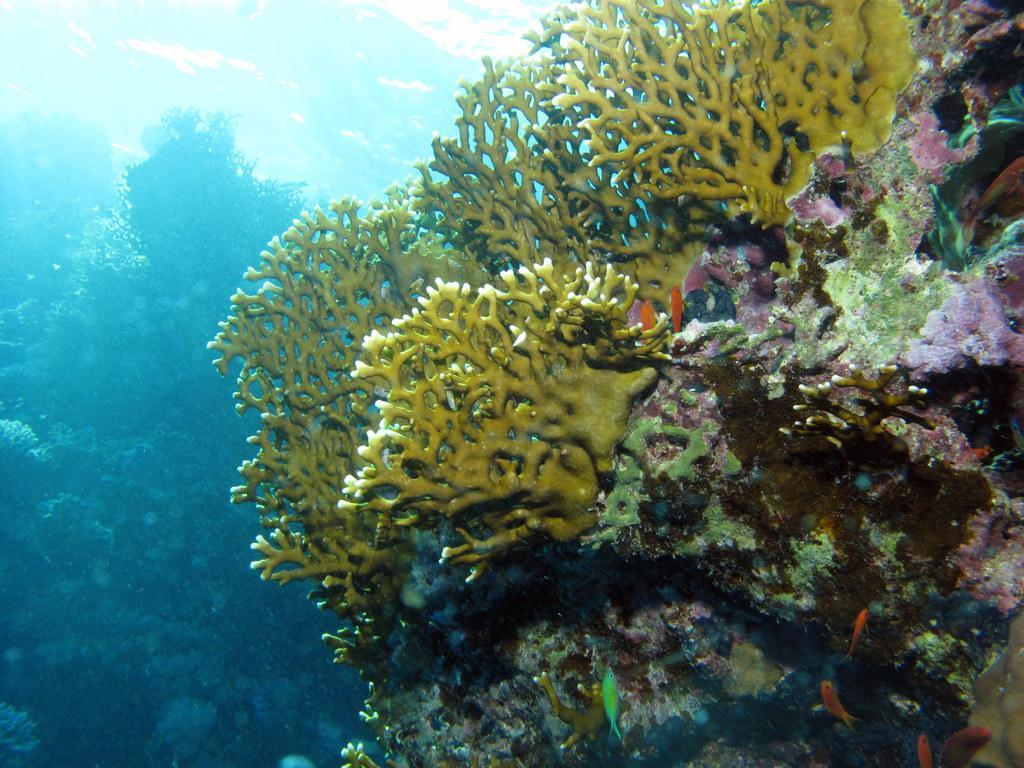What is visible in the image? There is water and plants visible in the image. Can you describe the water in the image? The water is visible, but its specific characteristics are not mentioned in the facts. What type of plants can be seen in the image? The facts do not specify the type of plants in the image. What time of day is depicted in the image? The facts provided do not mention the time of day, so it cannot be determined from the image. Can you describe the smile on the plants in the image? There are no faces or expressions, including smiles, present in the image, as it features water and plants. 